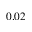Convert formula to latex. <formula><loc_0><loc_0><loc_500><loc_500>0 . 0 2</formula> 